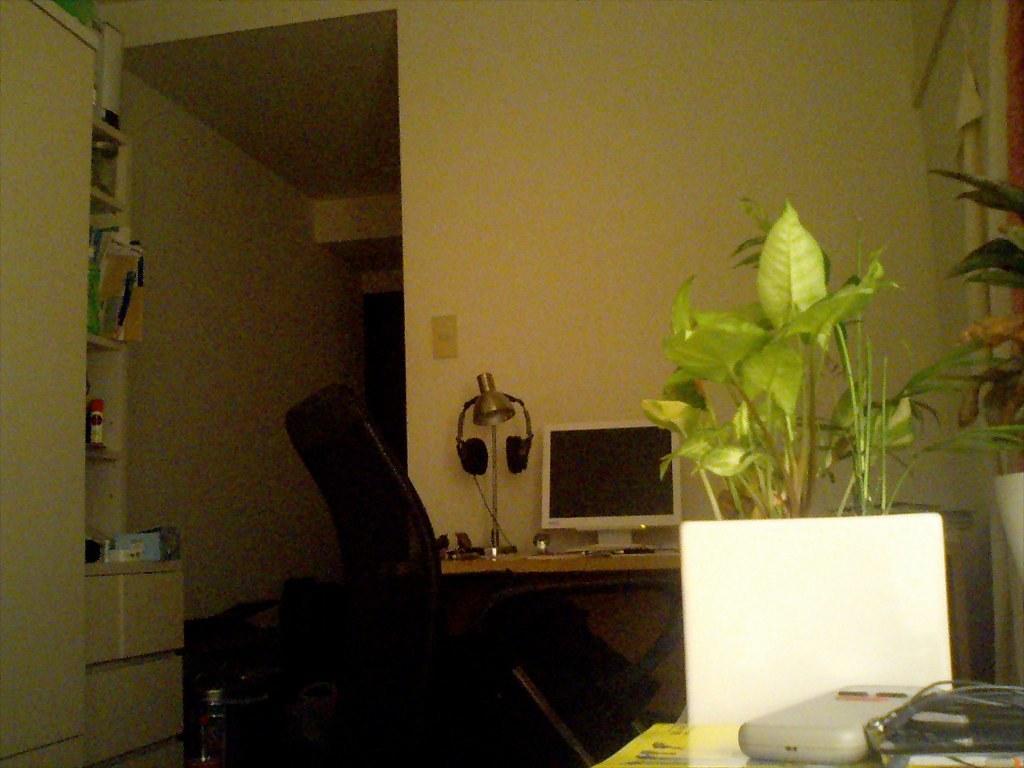Describe this image in one or two sentences. In this picture we can see a person is seated, beside to the person we can find a monitor, headphones and some other things on the table, in front of the person we can see few things in the racks, and also we can see few plants. 